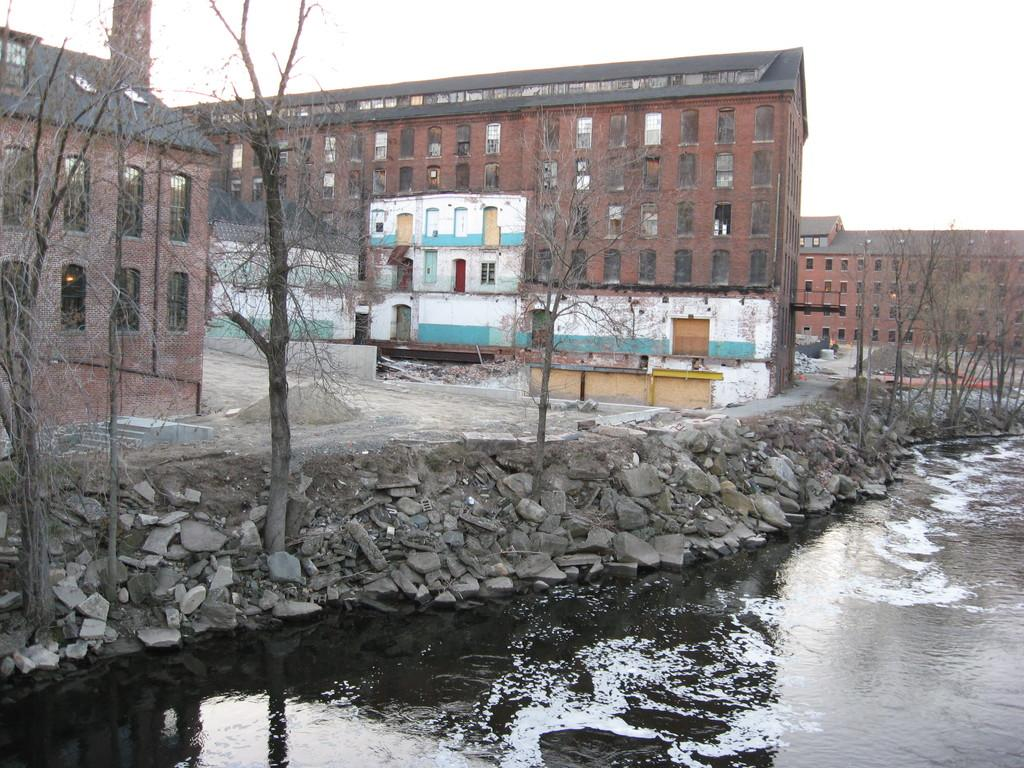What is the primary element visible in the image? There is water in the image. What other objects or features can be seen in the image? There are stones, trees, buildings, and the sky visible in the image. Can you describe the natural elements in the image? There are trees and water in the image, which suggests a natural setting. What type of structures are present in the image? There are buildings in the image, which indicates a human-made element. What type of paint is being used to create the prison scene in the image? There is no prison scene or paint present in the image; it features water, stones, trees, buildings, and the sky. 